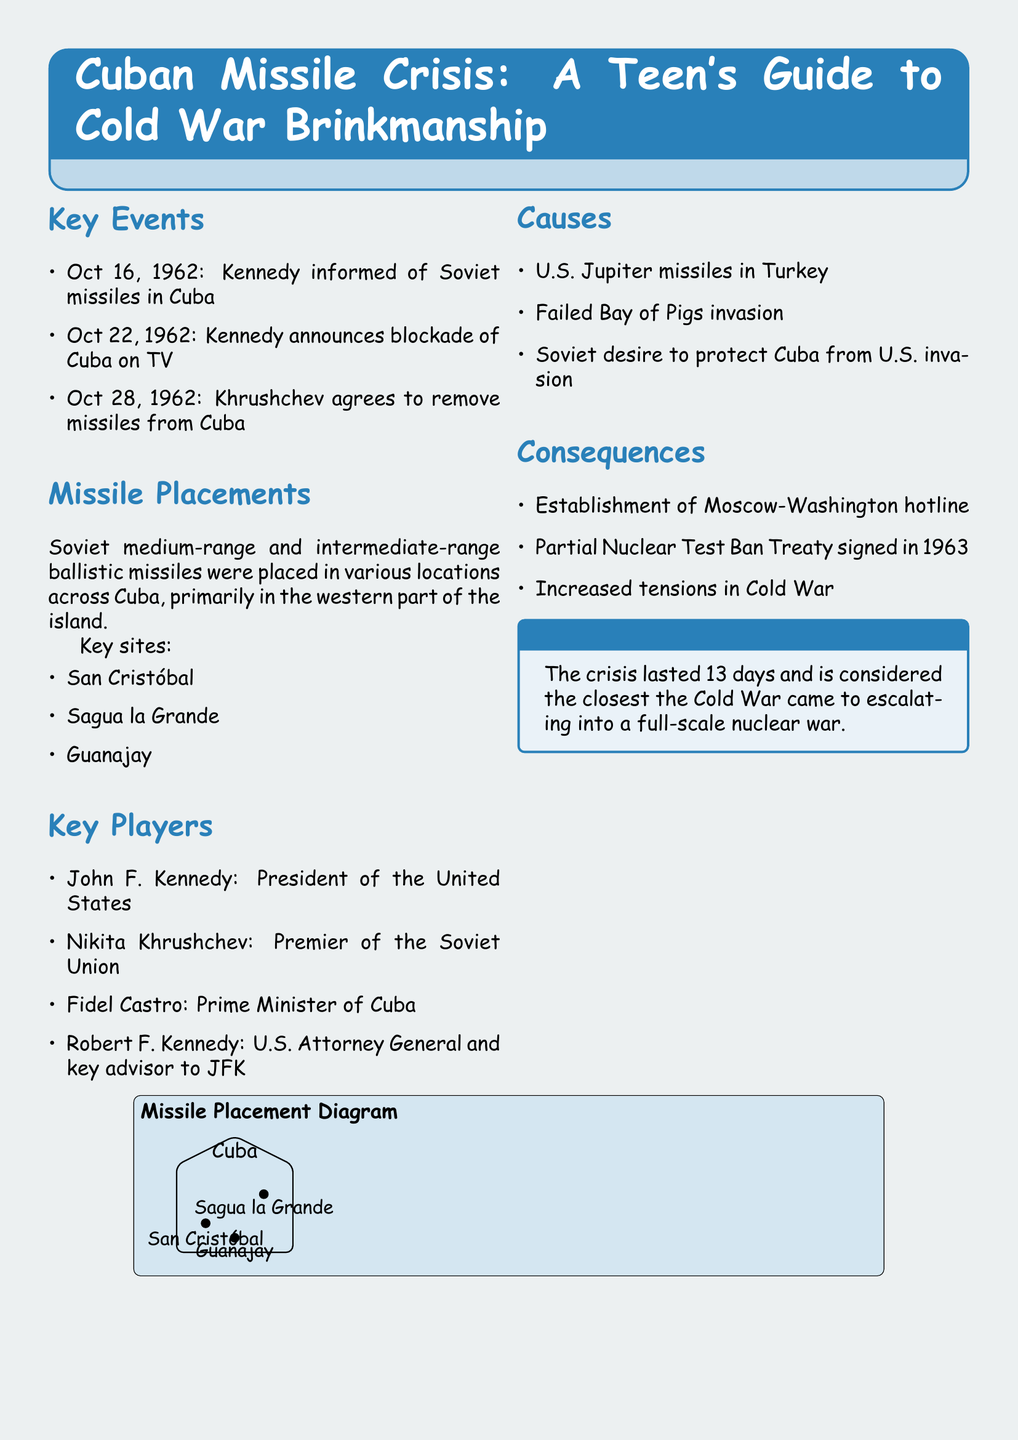What date did Kennedy announce the blockade of Cuba? This key event occurred on October 22, 1962, as mentioned in the document.
Answer: October 22, 1962 Who was the Prime Minister of Cuba during the crisis? The document lists Fidel Castro as the Prime Minister of Cuba during the Cuban Missile Crisis.
Answer: Fidel Castro What was established between Moscow and Washington as a consequence of the crisis? The document states that the establishment of a Moscow-Washington hotline was one of the consequences of the crisis.
Answer: Moscow-Washington hotline Name one of the key missile placement sites in Cuba. The document lists San Cristóbal, Sagua la Grande, and Guanajay as key missile placement sites in Cuba.
Answer: San Cristóbal What was a cause of the Cuban Missile Crisis related to U.S. military presence? The document mentions U.S. Jupiter missiles in Turkey as one of the causes.
Answer: U.S. Jupiter missiles in Turkey How many days did the Cuban Missile Crisis last? The interesting fact in the document states that the crisis lasted 13 days.
Answer: 13 days Who was a key advisor to JFK during the crisis? According to the document, Robert F. Kennedy served as U.S. Attorney General and key advisor to JFK.
Answer: Robert F. Kennedy What treaty was signed in 1963 as a consequence of the crisis? The document refers to the Partial Nuclear Test Ban Treaty signed in 1963 as a consequence.
Answer: Partial Nuclear Test Ban Treaty 